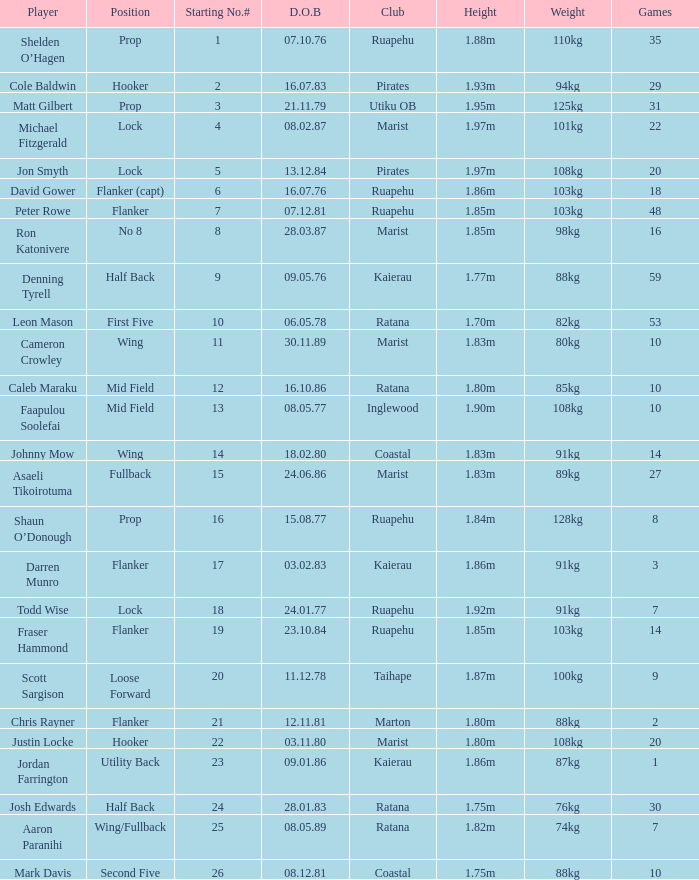How many games were played where the player's height is 1.0. 